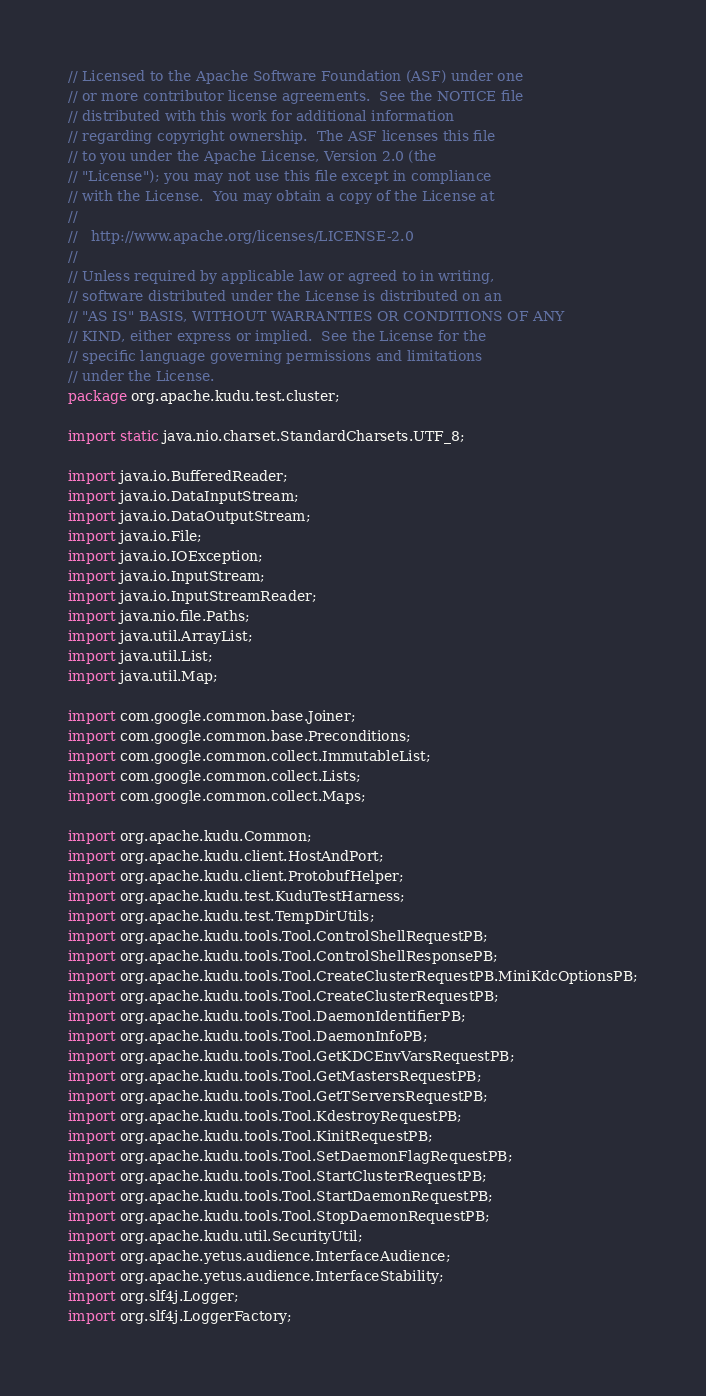Convert code to text. <code><loc_0><loc_0><loc_500><loc_500><_Java_>// Licensed to the Apache Software Foundation (ASF) under one
// or more contributor license agreements.  See the NOTICE file
// distributed with this work for additional information
// regarding copyright ownership.  The ASF licenses this file
// to you under the Apache License, Version 2.0 (the
// "License"); you may not use this file except in compliance
// with the License.  You may obtain a copy of the License at
//
//   http://www.apache.org/licenses/LICENSE-2.0
//
// Unless required by applicable law or agreed to in writing,
// software distributed under the License is distributed on an
// "AS IS" BASIS, WITHOUT WARRANTIES OR CONDITIONS OF ANY
// KIND, either express or implied.  See the License for the
// specific language governing permissions and limitations
// under the License.
package org.apache.kudu.test.cluster;

import static java.nio.charset.StandardCharsets.UTF_8;

import java.io.BufferedReader;
import java.io.DataInputStream;
import java.io.DataOutputStream;
import java.io.File;
import java.io.IOException;
import java.io.InputStream;
import java.io.InputStreamReader;
import java.nio.file.Paths;
import java.util.ArrayList;
import java.util.List;
import java.util.Map;

import com.google.common.base.Joiner;
import com.google.common.base.Preconditions;
import com.google.common.collect.ImmutableList;
import com.google.common.collect.Lists;
import com.google.common.collect.Maps;

import org.apache.kudu.Common;
import org.apache.kudu.client.HostAndPort;
import org.apache.kudu.client.ProtobufHelper;
import org.apache.kudu.test.KuduTestHarness;
import org.apache.kudu.test.TempDirUtils;
import org.apache.kudu.tools.Tool.ControlShellRequestPB;
import org.apache.kudu.tools.Tool.ControlShellResponsePB;
import org.apache.kudu.tools.Tool.CreateClusterRequestPB.MiniKdcOptionsPB;
import org.apache.kudu.tools.Tool.CreateClusterRequestPB;
import org.apache.kudu.tools.Tool.DaemonIdentifierPB;
import org.apache.kudu.tools.Tool.DaemonInfoPB;
import org.apache.kudu.tools.Tool.GetKDCEnvVarsRequestPB;
import org.apache.kudu.tools.Tool.GetMastersRequestPB;
import org.apache.kudu.tools.Tool.GetTServersRequestPB;
import org.apache.kudu.tools.Tool.KdestroyRequestPB;
import org.apache.kudu.tools.Tool.KinitRequestPB;
import org.apache.kudu.tools.Tool.SetDaemonFlagRequestPB;
import org.apache.kudu.tools.Tool.StartClusterRequestPB;
import org.apache.kudu.tools.Tool.StartDaemonRequestPB;
import org.apache.kudu.tools.Tool.StopDaemonRequestPB;
import org.apache.kudu.util.SecurityUtil;
import org.apache.yetus.audience.InterfaceAudience;
import org.apache.yetus.audience.InterfaceStability;
import org.slf4j.Logger;
import org.slf4j.LoggerFactory;
</code> 